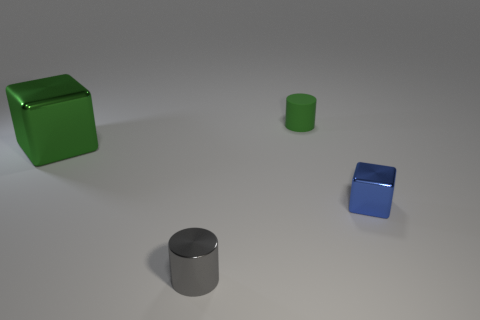Add 1 small yellow balls. How many objects exist? 5 Add 1 metal objects. How many metal objects are left? 4 Add 1 green cylinders. How many green cylinders exist? 2 Subtract 0 purple blocks. How many objects are left? 4 Subtract all blue rubber cylinders. Subtract all tiny gray objects. How many objects are left? 3 